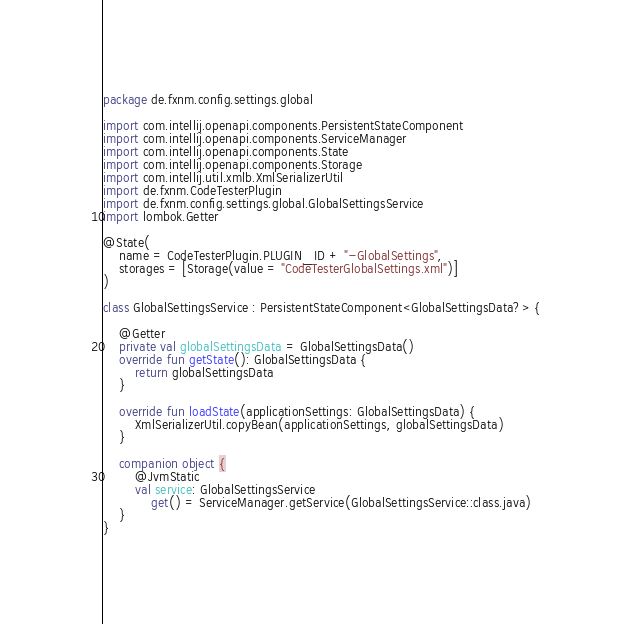Convert code to text. <code><loc_0><loc_0><loc_500><loc_500><_Kotlin_>package de.fxnm.config.settings.global

import com.intellij.openapi.components.PersistentStateComponent
import com.intellij.openapi.components.ServiceManager
import com.intellij.openapi.components.State
import com.intellij.openapi.components.Storage
import com.intellij.util.xmlb.XmlSerializerUtil
import de.fxnm.CodeTesterPlugin
import de.fxnm.config.settings.global.GlobalSettingsService
import lombok.Getter

@State(
    name = CodeTesterPlugin.PLUGIN_ID + "-GlobalSettings",
    storages = [Storage(value = "CodeTesterGlobalSettings.xml")]
)

class GlobalSettingsService : PersistentStateComponent<GlobalSettingsData?> {

    @Getter
    private val globalSettingsData = GlobalSettingsData()
    override fun getState(): GlobalSettingsData {
        return globalSettingsData
    }

    override fun loadState(applicationSettings: GlobalSettingsData) {
        XmlSerializerUtil.copyBean(applicationSettings, globalSettingsData)
    }

    companion object {
        @JvmStatic
        val service: GlobalSettingsService
            get() = ServiceManager.getService(GlobalSettingsService::class.java)
    }
}
</code> 